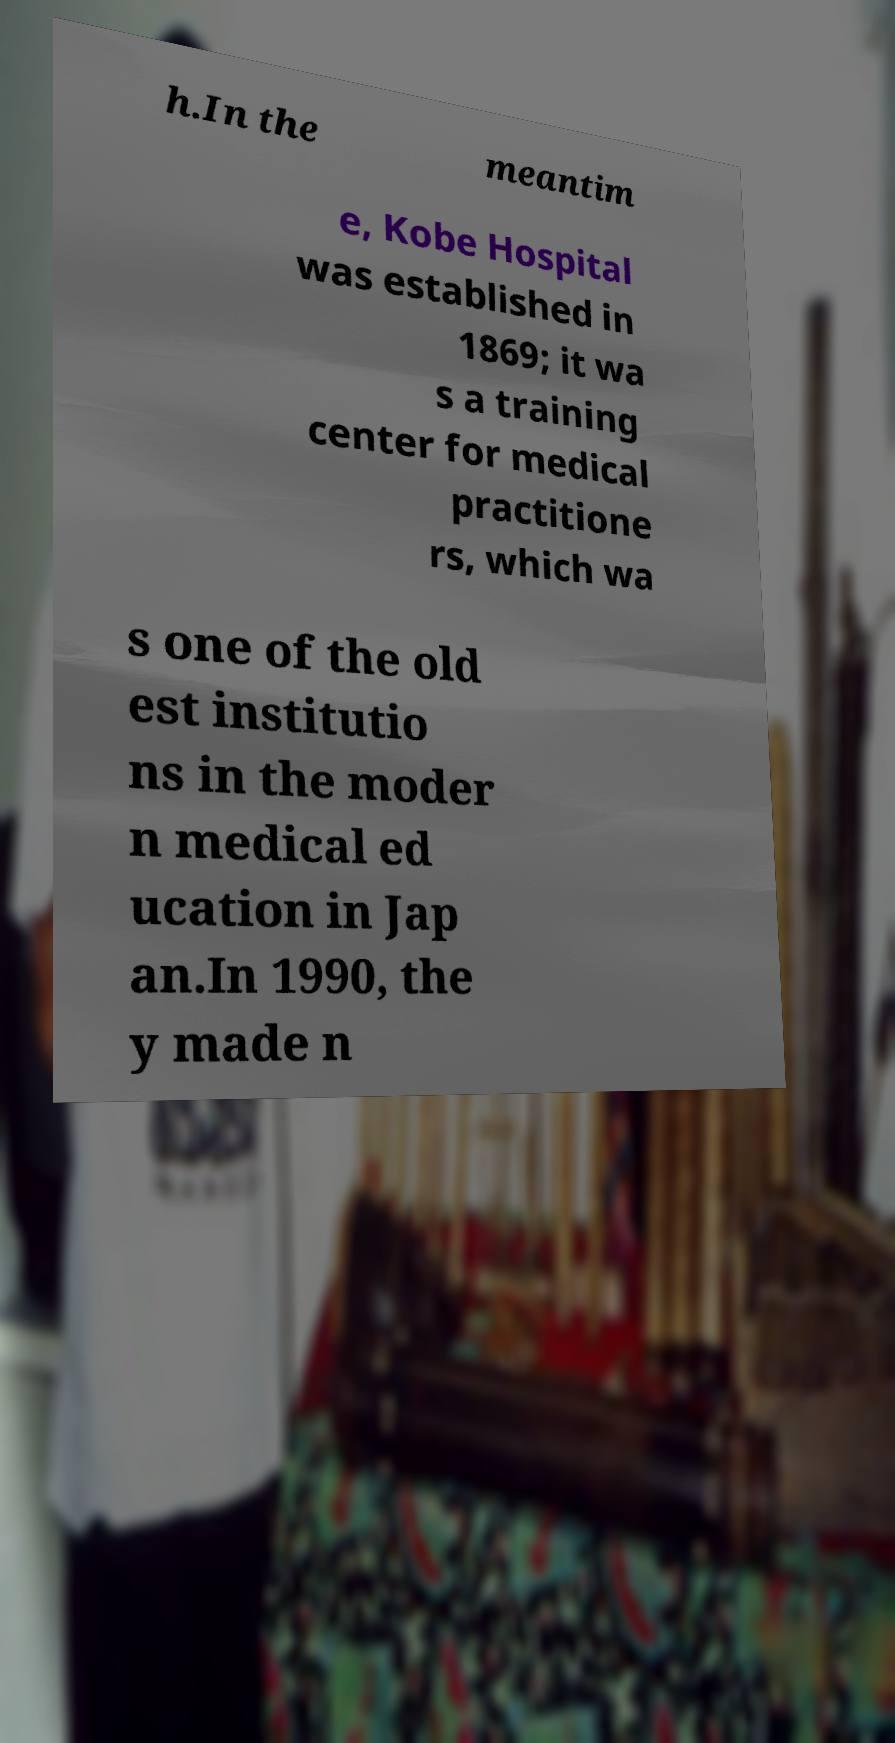Can you read and provide the text displayed in the image?This photo seems to have some interesting text. Can you extract and type it out for me? h.In the meantim e, Kobe Hospital was established in 1869; it wa s a training center for medical practitione rs, which wa s one of the old est institutio ns in the moder n medical ed ucation in Jap an.In 1990, the y made n 